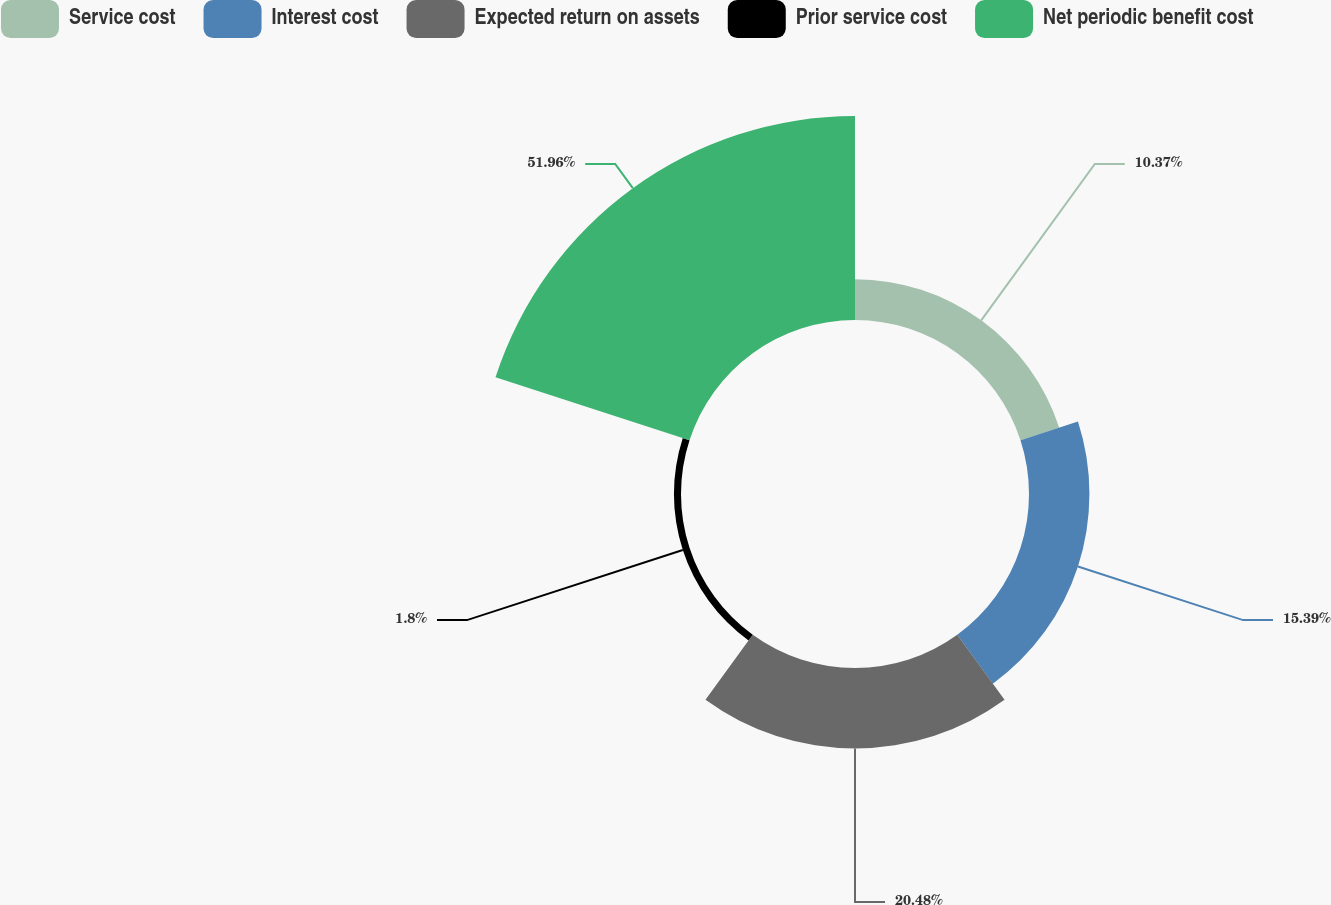<chart> <loc_0><loc_0><loc_500><loc_500><pie_chart><fcel>Service cost<fcel>Interest cost<fcel>Expected return on assets<fcel>Prior service cost<fcel>Net periodic benefit cost<nl><fcel>10.37%<fcel>15.39%<fcel>20.48%<fcel>1.8%<fcel>51.96%<nl></chart> 